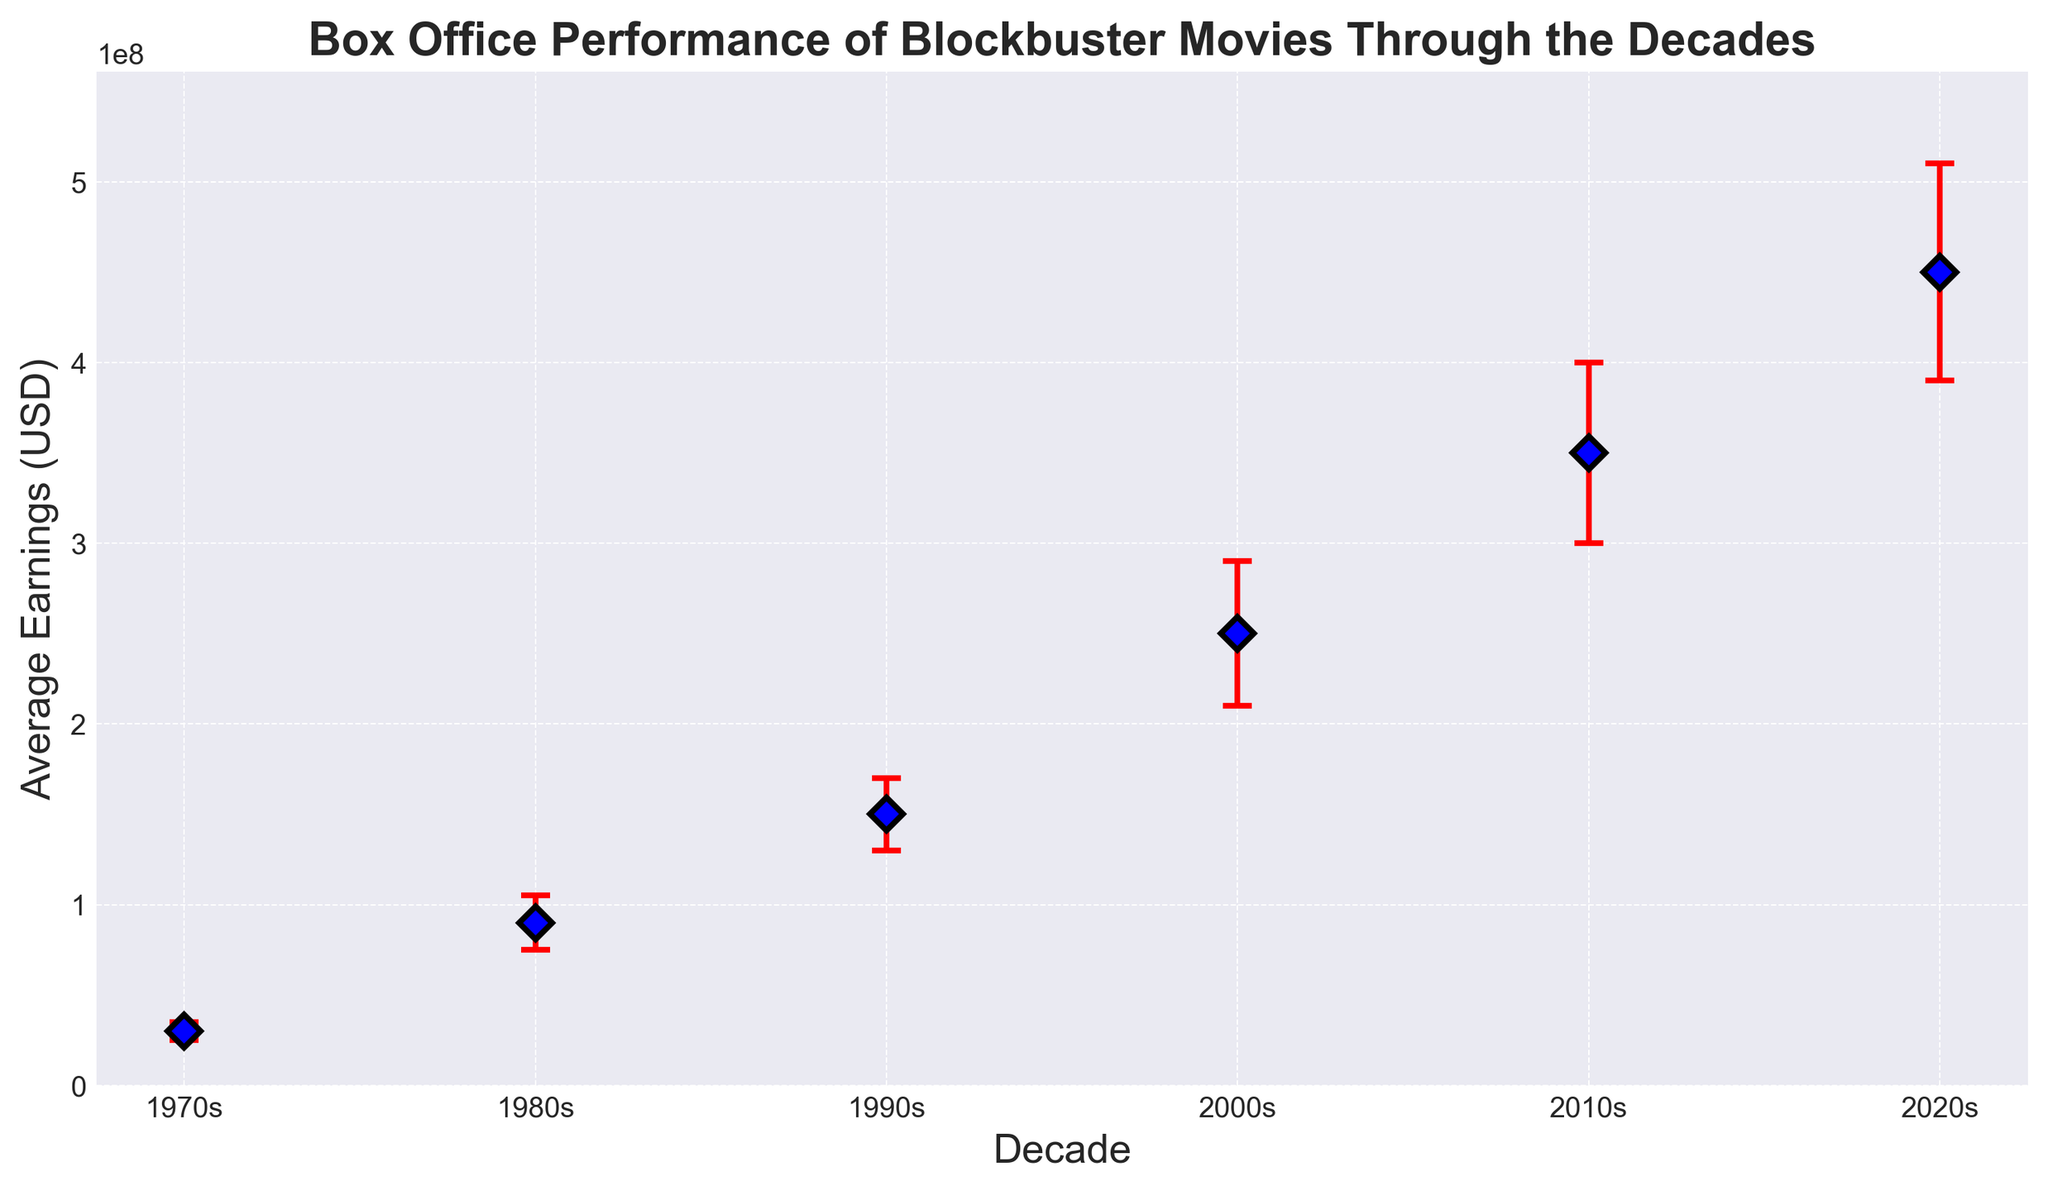What decade has the highest average box office earnings? The 2020s show the highest average earnings at $450,000,000 compared to previous decades.
Answer: 2020s By how much did the average earnings increase from the 1990s to the 2000s? The average earnings in the 1990s were $150,000,000 and in the 2000s were $250,000,000. The difference is $250,000,000 - $150,000,000 = $100,000,000.
Answer: $100,000,000 Which decade exhibits the largest standard deviation in earnings? The 2020s exhibit the largest standard deviation of $60,000,000, as shown by the length of the error bars.
Answer: 2020s Is there any decade where the error bars of average earnings do not overlap with the previous decade's earnings range? From 1980s ($90,000,000 ± $15,000,000) to 1990s ($150,000,000 ± $20,000,000), the error bars do not overlap. This is because the earnings range for the 1980s is $75,000,000 to $105,000,000 (lower bound $90,000,000 - $15,000,000, upper bound $90,000,000 + $15,000,000) and for the 1990s is $130,000,000 to $170,000,000, which do not intersect.
Answer: 1980s to 1990s What is the average annual growth rate of the earnings from the 1970s to the 2020s? The earnings in the 1970s are $30,000,000 and in the 2020s they are $450,000,000. The number of decades between them is 5. The growth rate "r" can be calculated using the formula: \[ 450,000,000 = 30,000,000 \times (1 + r)^5 \]. Solving for "r" via logarithms, we get \[ r \approx 0.325 \] or 32.5%.
Answer: 32.5% Which decade represents the highest relative increase in average earnings compared to the previous decade? The largest relative increase occurred between the 1970s and 1980s. The increase is \[ \frac{90,000,000 - 30,000,000}{30,000,000} \approx 2 \text{ or } 200% \].
Answer: 1970s to 1980s Are there any decades where the average earnings show a decline from the previous decade? No, each succeeding decade depicts an increase in average earnings compared to the previous one.
Answer: No Comparing the range (average ± standard deviation) of earnings, which two decades have the most similar ranges? The 1990s (ranging from $130,000,000 to $170,000,000) and the 1980s (ranging from $75,000,000 to $105,000,000) have the most similar ranges with slight overlap.
Answer: 1980s and 1990s What's the combined range of earnings for the 2000s and 2010s? The 2000s range from $210,000,000 to $290,000,000, and the 2010s range from $300,000,000 to $400,000,000. The combined range is from $210,000,000 (lowest value of 2000s) to $400,000,000 (highest value of 2010s).
Answer: $210,000,000 to $400,000,000 